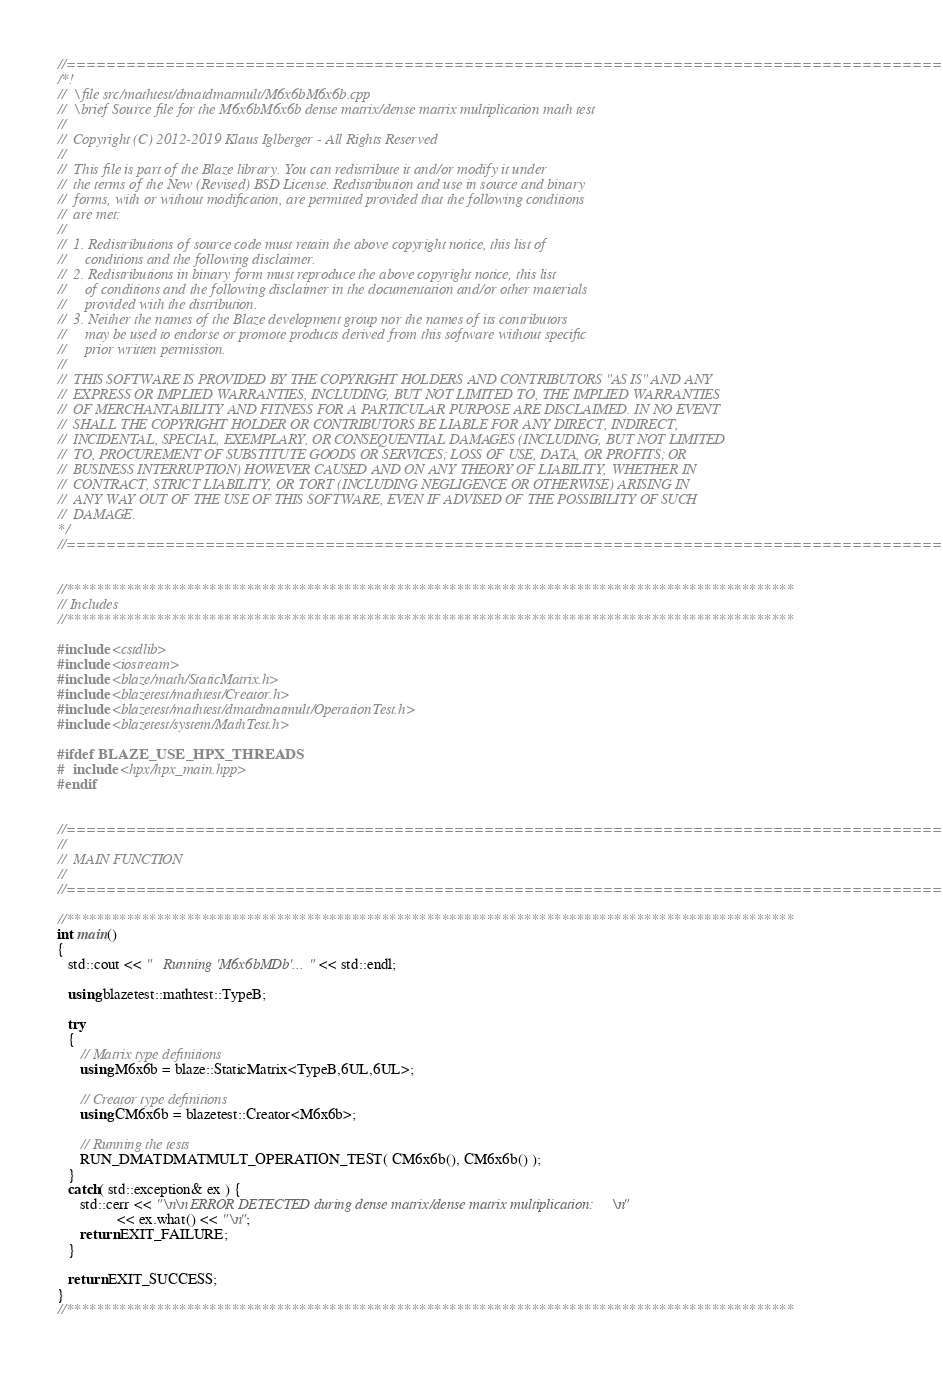Convert code to text. <code><loc_0><loc_0><loc_500><loc_500><_C++_>//=================================================================================================
/*!
//  \file src/mathtest/dmatdmatmult/M6x6bM6x6b.cpp
//  \brief Source file for the M6x6bM6x6b dense matrix/dense matrix multiplication math test
//
//  Copyright (C) 2012-2019 Klaus Iglberger - All Rights Reserved
//
//  This file is part of the Blaze library. You can redistribute it and/or modify it under
//  the terms of the New (Revised) BSD License. Redistribution and use in source and binary
//  forms, with or without modification, are permitted provided that the following conditions
//  are met:
//
//  1. Redistributions of source code must retain the above copyright notice, this list of
//     conditions and the following disclaimer.
//  2. Redistributions in binary form must reproduce the above copyright notice, this list
//     of conditions and the following disclaimer in the documentation and/or other materials
//     provided with the distribution.
//  3. Neither the names of the Blaze development group nor the names of its contributors
//     may be used to endorse or promote products derived from this software without specific
//     prior written permission.
//
//  THIS SOFTWARE IS PROVIDED BY THE COPYRIGHT HOLDERS AND CONTRIBUTORS "AS IS" AND ANY
//  EXPRESS OR IMPLIED WARRANTIES, INCLUDING, BUT NOT LIMITED TO, THE IMPLIED WARRANTIES
//  OF MERCHANTABILITY AND FITNESS FOR A PARTICULAR PURPOSE ARE DISCLAIMED. IN NO EVENT
//  SHALL THE COPYRIGHT HOLDER OR CONTRIBUTORS BE LIABLE FOR ANY DIRECT, INDIRECT,
//  INCIDENTAL, SPECIAL, EXEMPLARY, OR CONSEQUENTIAL DAMAGES (INCLUDING, BUT NOT LIMITED
//  TO, PROCUREMENT OF SUBSTITUTE GOODS OR SERVICES; LOSS OF USE, DATA, OR PROFITS; OR
//  BUSINESS INTERRUPTION) HOWEVER CAUSED AND ON ANY THEORY OF LIABILITY, WHETHER IN
//  CONTRACT, STRICT LIABILITY, OR TORT (INCLUDING NEGLIGENCE OR OTHERWISE) ARISING IN
//  ANY WAY OUT OF THE USE OF THIS SOFTWARE, EVEN IF ADVISED OF THE POSSIBILITY OF SUCH
//  DAMAGE.
*/
//=================================================================================================


//*************************************************************************************************
// Includes
//*************************************************************************************************

#include <cstdlib>
#include <iostream>
#include <blaze/math/StaticMatrix.h>
#include <blazetest/mathtest/Creator.h>
#include <blazetest/mathtest/dmatdmatmult/OperationTest.h>
#include <blazetest/system/MathTest.h>

#ifdef BLAZE_USE_HPX_THREADS
#  include <hpx/hpx_main.hpp>
#endif


//=================================================================================================
//
//  MAIN FUNCTION
//
//=================================================================================================

//*************************************************************************************************
int main()
{
   std::cout << "   Running 'M6x6bMDb'..." << std::endl;

   using blazetest::mathtest::TypeB;

   try
   {
      // Matrix type definitions
      using M6x6b = blaze::StaticMatrix<TypeB,6UL,6UL>;

      // Creator type definitions
      using CM6x6b = blazetest::Creator<M6x6b>;

      // Running the tests
      RUN_DMATDMATMULT_OPERATION_TEST( CM6x6b(), CM6x6b() );
   }
   catch( std::exception& ex ) {
      std::cerr << "\n\n ERROR DETECTED during dense matrix/dense matrix multiplication:\n"
                << ex.what() << "\n";
      return EXIT_FAILURE;
   }

   return EXIT_SUCCESS;
}
//*************************************************************************************************
</code> 